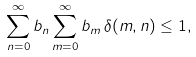Convert formula to latex. <formula><loc_0><loc_0><loc_500><loc_500>\sum _ { n = 0 } ^ { \infty } b _ { n } \sum _ { m = 0 } ^ { \infty } b _ { m } \, \delta ( m , n ) \leq 1 ,</formula> 